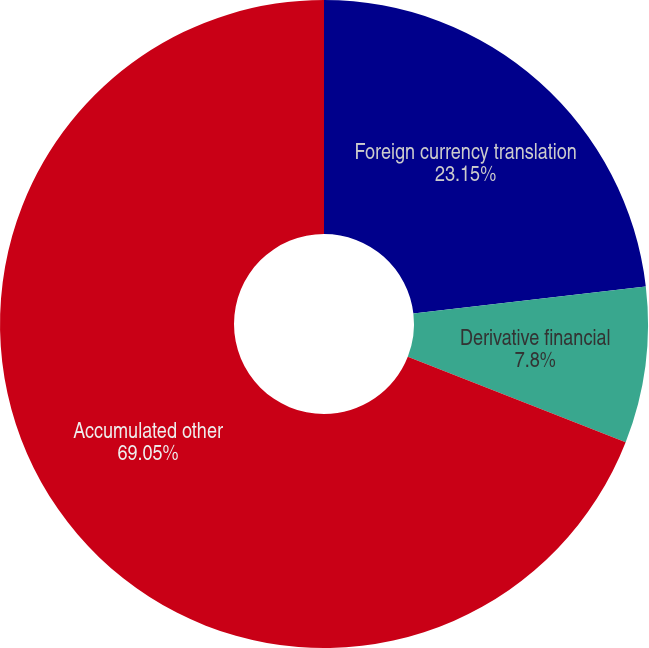<chart> <loc_0><loc_0><loc_500><loc_500><pie_chart><fcel>Foreign currency translation<fcel>Derivative financial<fcel>Accumulated other<nl><fcel>23.15%<fcel>7.8%<fcel>69.06%<nl></chart> 